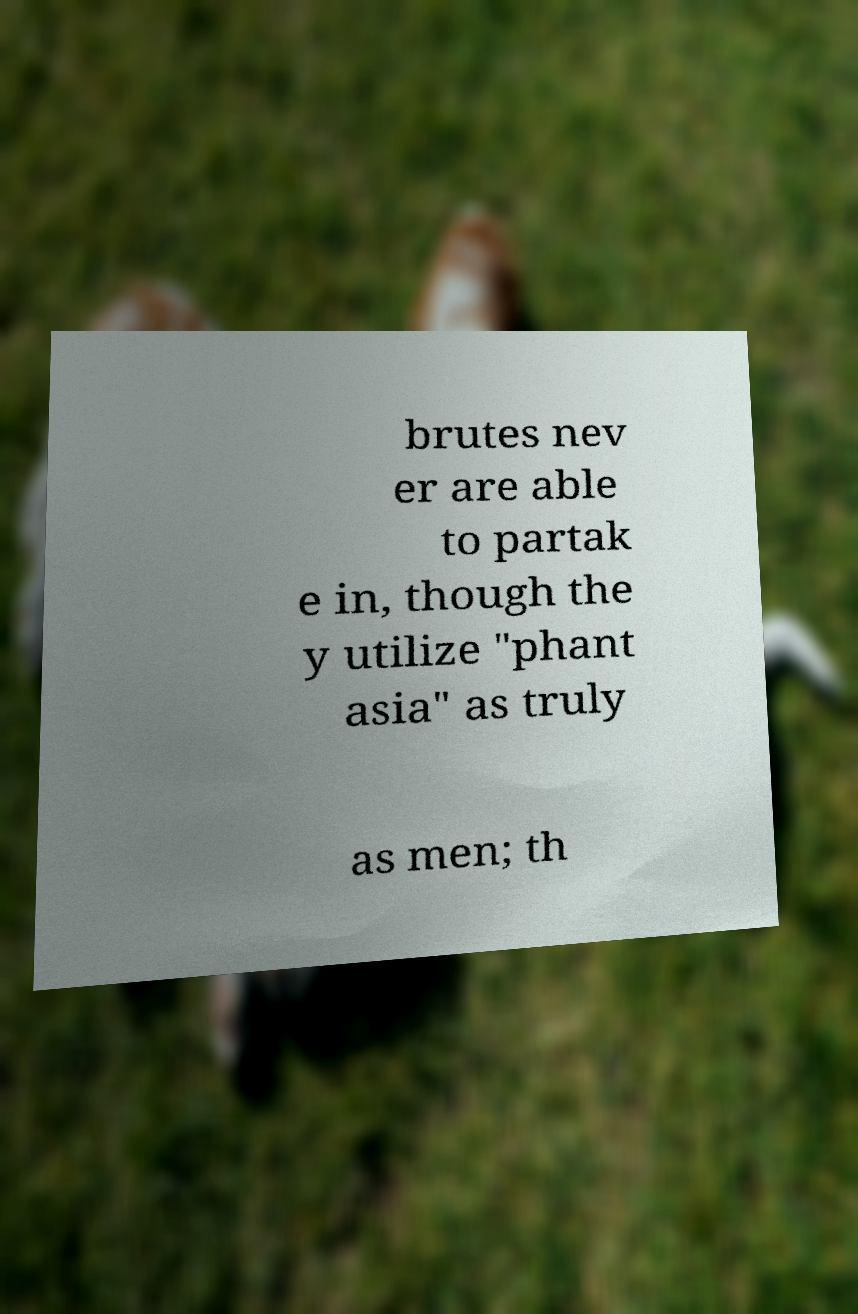Please identify and transcribe the text found in this image. brutes nev er are able to partak e in, though the y utilize "phant asia" as truly as men; th 